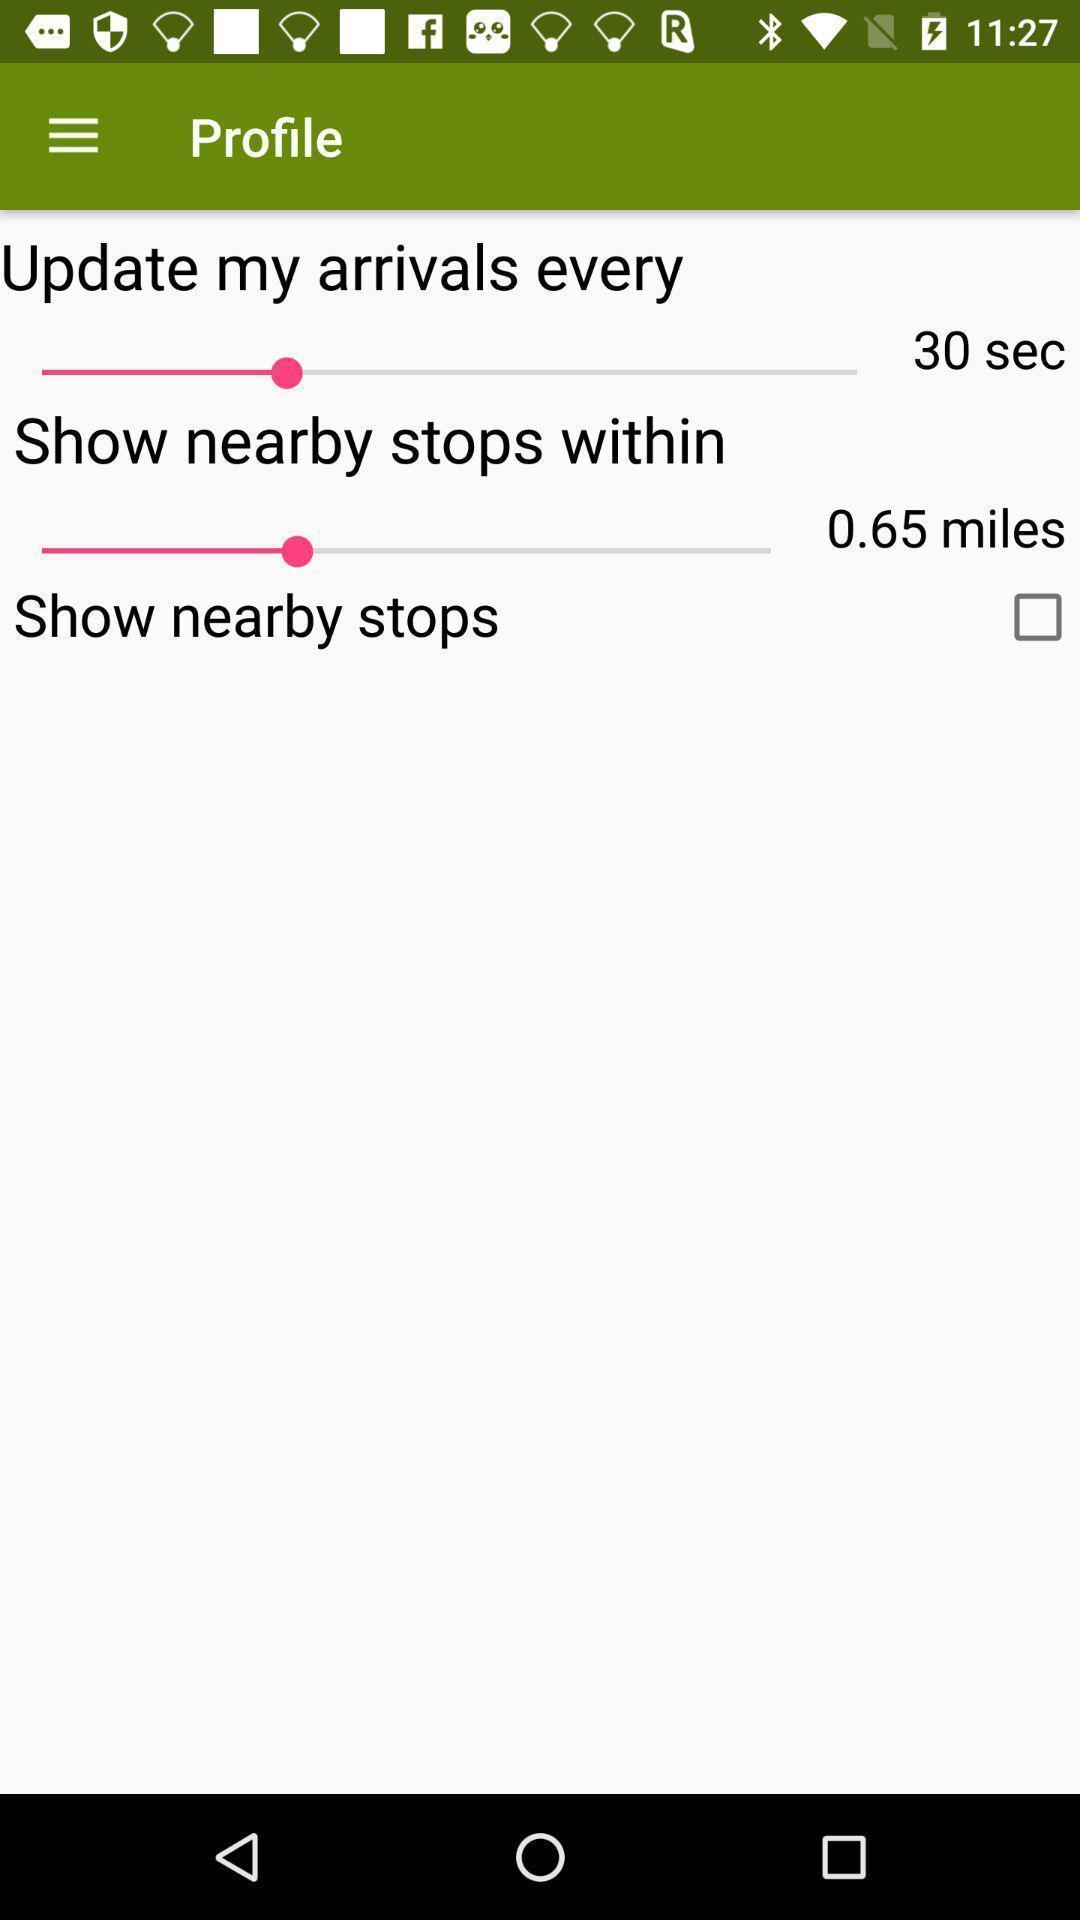What details can you identify in this image? Screen displaying the options for timer. 